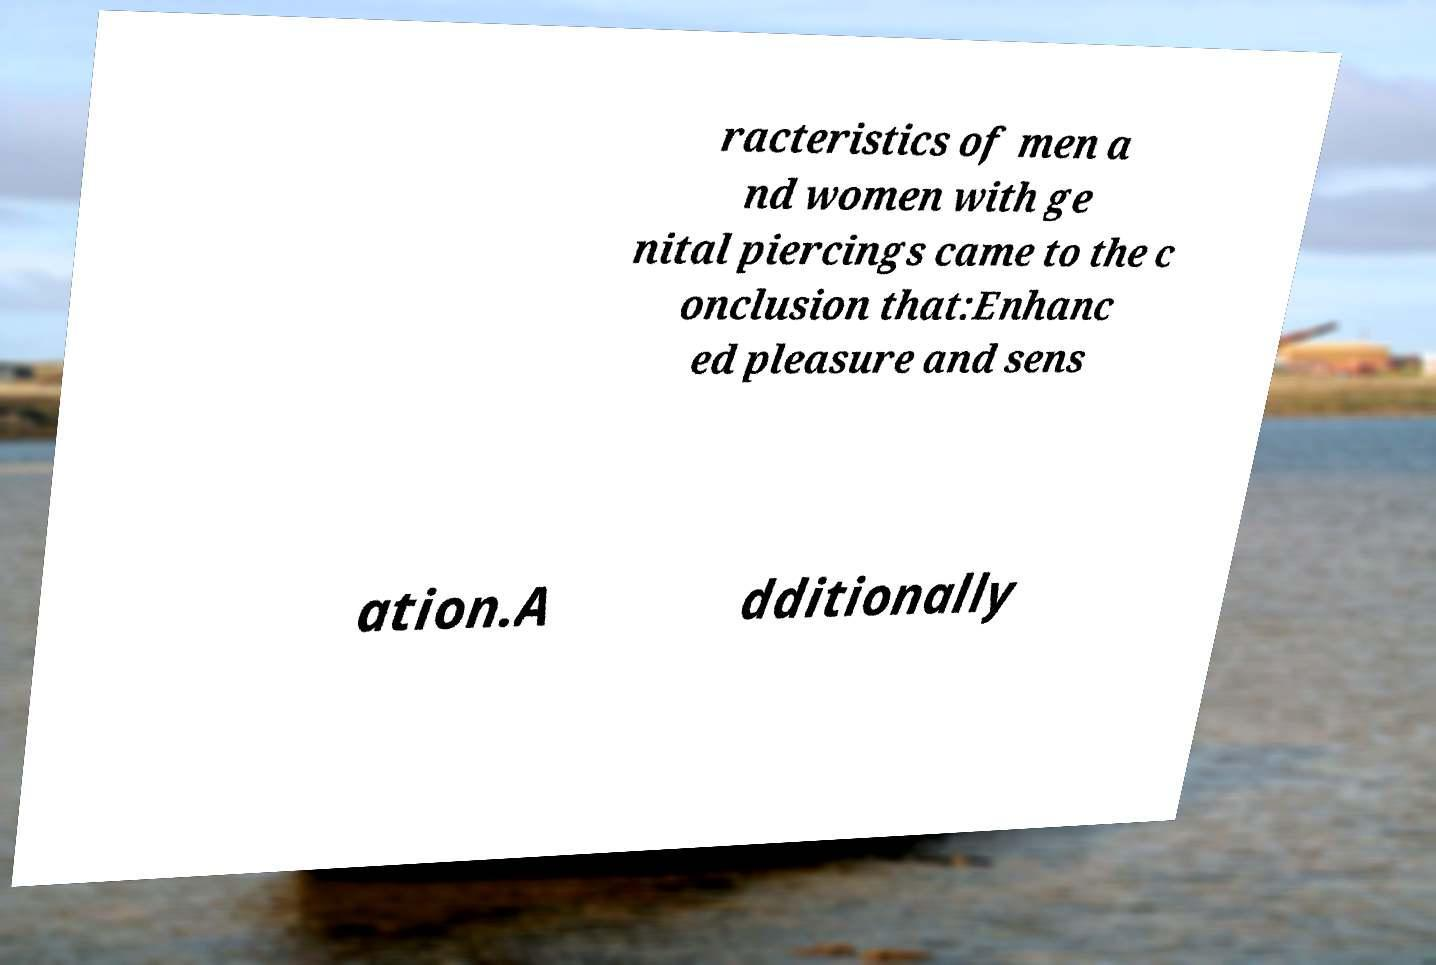There's text embedded in this image that I need extracted. Can you transcribe it verbatim? racteristics of men a nd women with ge nital piercings came to the c onclusion that:Enhanc ed pleasure and sens ation.A dditionally 